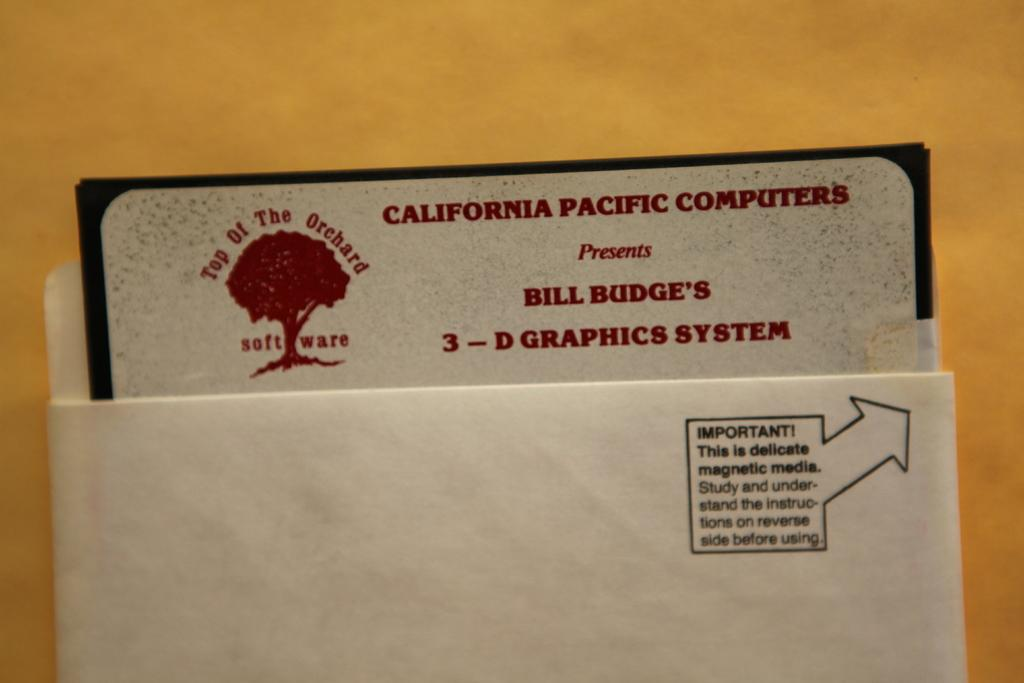<image>
Write a terse but informative summary of the picture. Inside an envelop is a piece of paper that reads California Pacific Computers. 